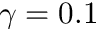Convert formula to latex. <formula><loc_0><loc_0><loc_500><loc_500>\gamma = 0 . 1</formula> 